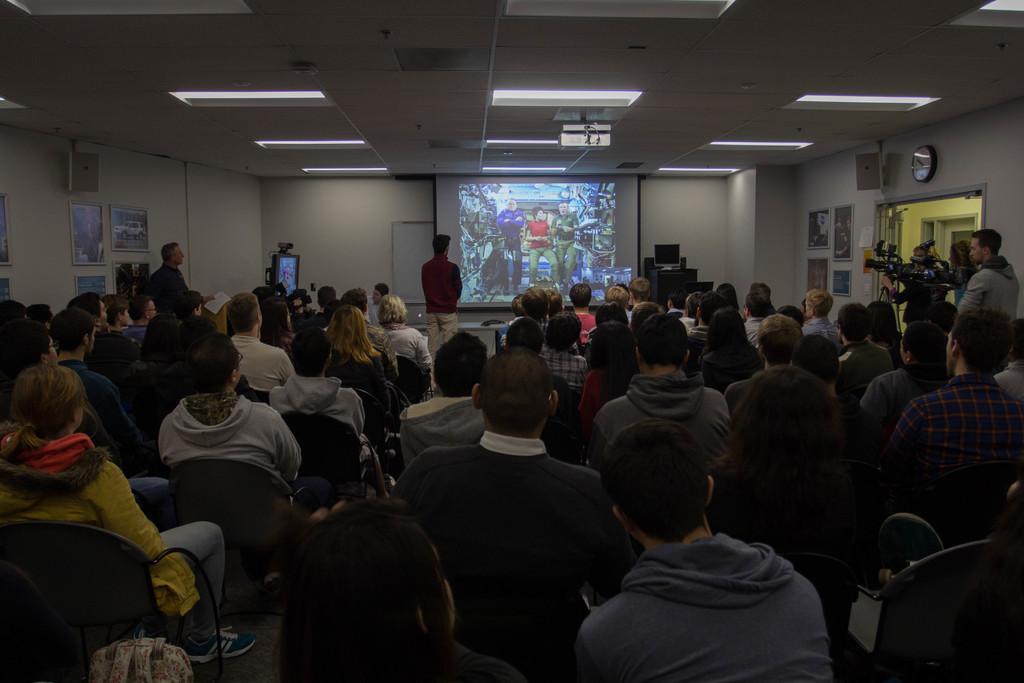Can you describe this image briefly? In this image there are people sitting and some of them are standing. On the right there is a camera placed on the stand. We can see a computer placed on the stand and there is a speaker. There is a door and we can see frames placed on the wall. At the top there are lights and we can see a screen. 